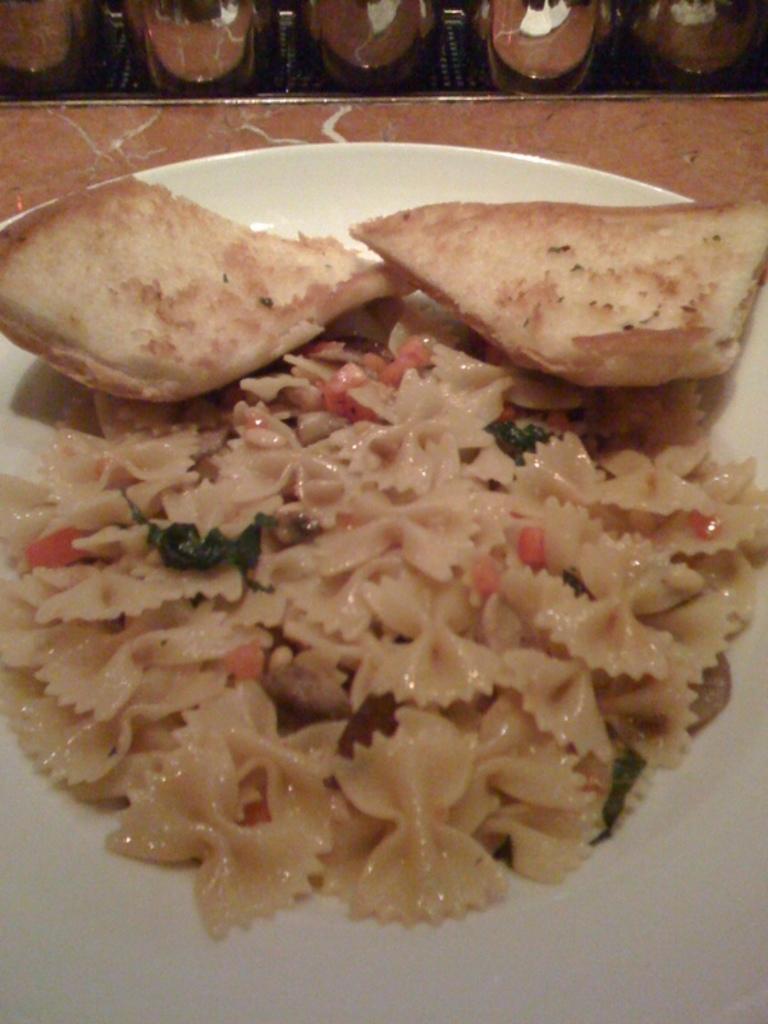How would you summarize this image in a sentence or two? In the image we can see a plate white in color, in the plate there is a food item and pieces of bread. 